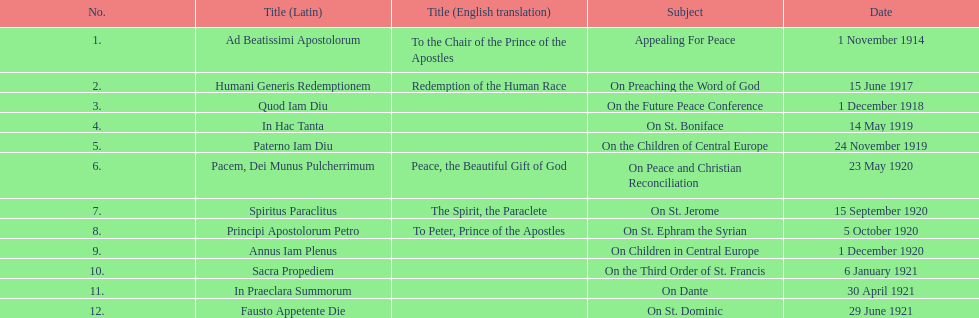What are the number of titles with a date of november? 2. 